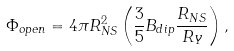Convert formula to latex. <formula><loc_0><loc_0><loc_500><loc_500>\Phi _ { o p e n } = 4 \pi R _ { N S } ^ { 2 } \left ( \frac { 3 } { 5 } B _ { d i p } \frac { R _ { N S } } { R _ { Y } } \right ) ,</formula> 